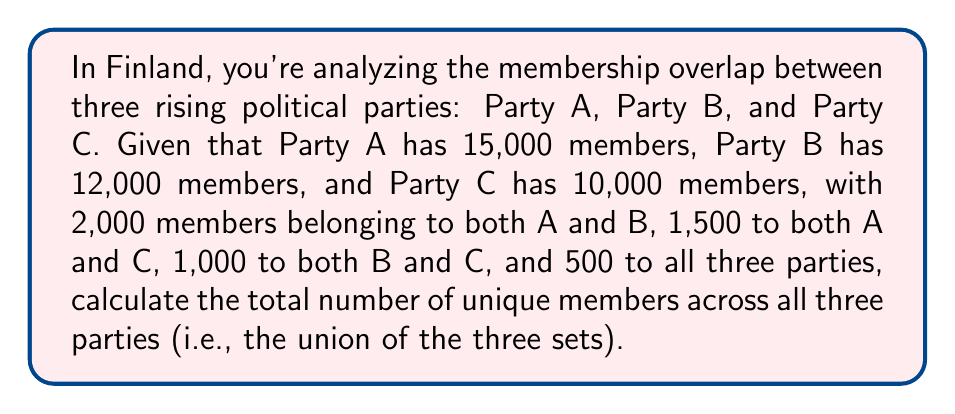Can you answer this question? To solve this problem, we'll use the principle of inclusion-exclusion for three sets. Let's define our sets:

$A$: members of Party A
$B$: members of Party B
$C$: members of Party C

We're given:
$|A| = 15000$, $|B| = 12000$, $|C| = 10000$
$|A \cap B| = 2000$, $|A \cap C| = 1500$, $|B \cap C| = 1000$
$|A \cap B \cap C| = 500$

The formula for the union of three sets is:

$$|A \cup B \cup C| = |A| + |B| + |C| - |A \cap B| - |A \cap C| - |B \cap C| + |A \cap B \cap C|$$

Let's substitute our values:

$$|A \cup B \cup C| = 15000 + 12000 + 10000 - 2000 - 1500 - 1000 + 500$$

Now we can calculate:

$$|A \cup B \cup C| = 37000 - 4500 + 500 = 33000$$

Therefore, the total number of unique members across all three parties is 33,000.
Answer: 33,000 members 